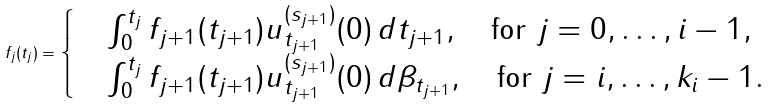<formula> <loc_0><loc_0><loc_500><loc_500>f _ { j } ( t _ { j } ) = \begin{cases} & \int _ { 0 } ^ { t _ { j } } f _ { j + 1 } ( t _ { j + 1 } ) u ^ { ( s _ { j + 1 } ) } _ { t _ { j + 1 } } ( 0 ) \, d t _ { j + 1 } , \quad \text {for } j = 0 , \dots , i - 1 , \\ & \int _ { 0 } ^ { t _ { j } } f _ { j + 1 } ( t _ { j + 1 } ) u ^ { ( s _ { j + 1 } ) } _ { t _ { j + 1 } } ( 0 ) \, d \beta _ { t _ { j + 1 } } , \quad \text {for } j = i , \dots , k _ { i } - 1 . \end{cases}</formula> 